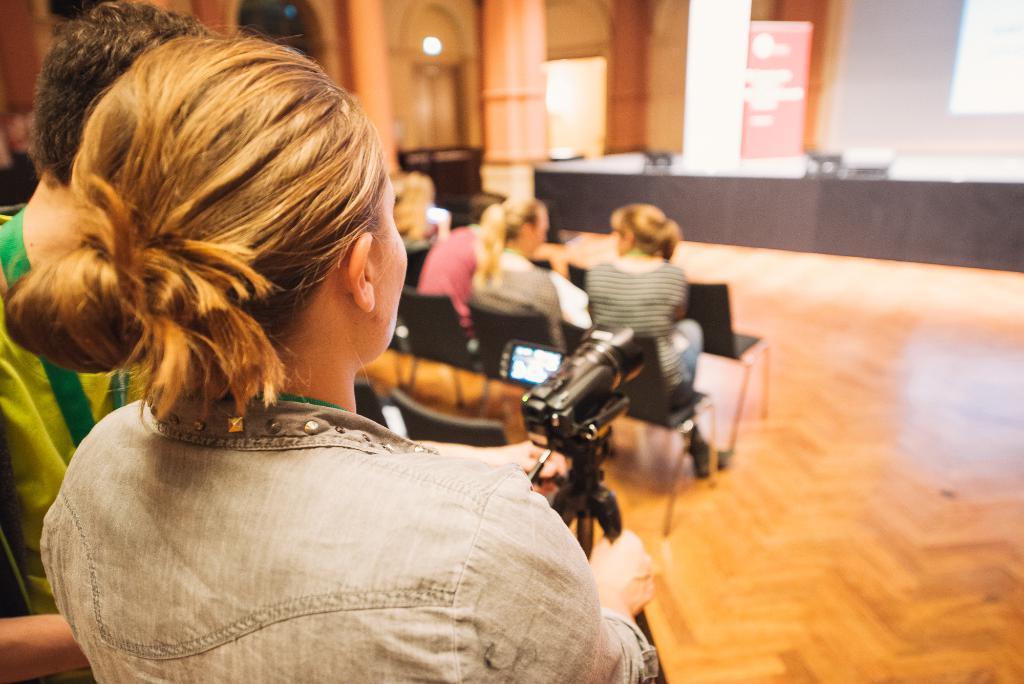Please provide a concise description of this image. In this picture we can see a woman is holding a tripod in the front, there is a video camera on the tripod, we can see three persons are sitting on chairs in the middle, it looks like a screen in the background. 